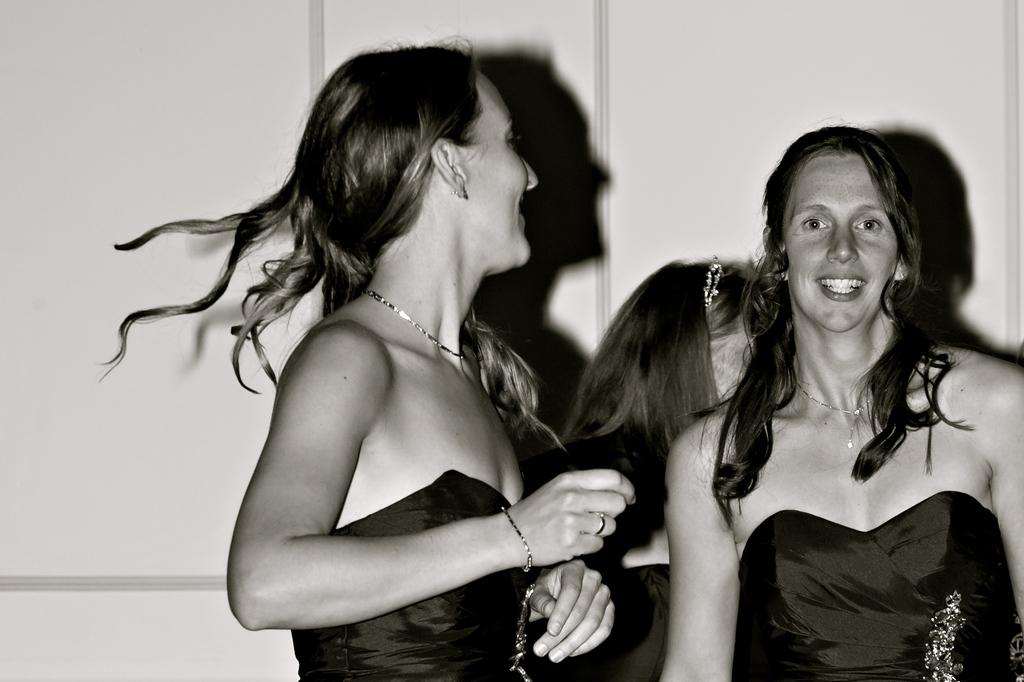How many people are in the image? There are three persons in the image. What are the persons doing in the image? The persons are standing near a wall. What type of blade can be seen in the image? There is no blade present in the image. What type of humor is being displayed by the persons in the image? There is no indication of humor being displayed by the persons in the image. 